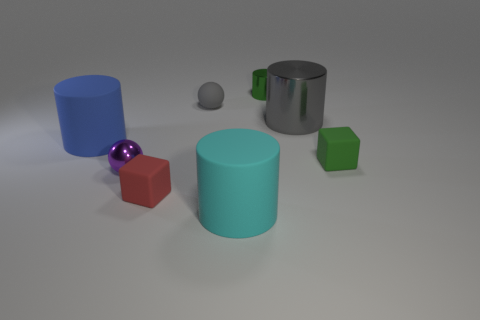Subtract 1 cylinders. How many cylinders are left? 3 Add 2 cyan matte objects. How many objects exist? 10 Subtract all spheres. How many objects are left? 6 Subtract all gray metal objects. Subtract all balls. How many objects are left? 5 Add 3 tiny red matte objects. How many tiny red matte objects are left? 4 Add 3 large purple rubber balls. How many large purple rubber balls exist? 3 Subtract 1 red blocks. How many objects are left? 7 